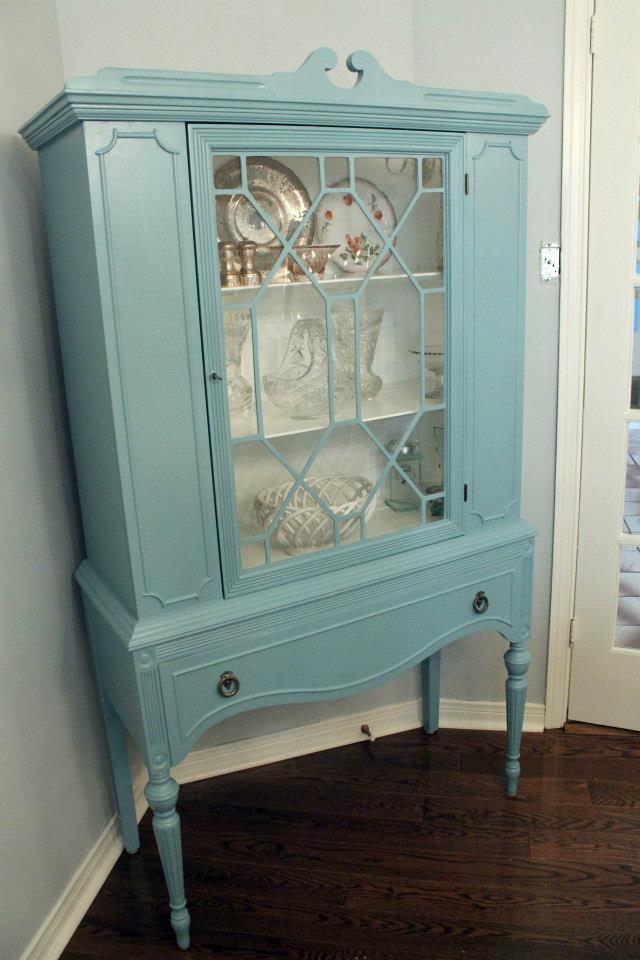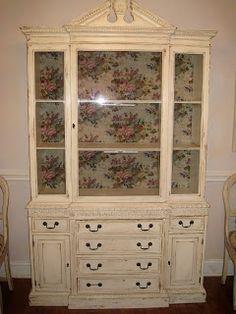The first image is the image on the left, the second image is the image on the right. Analyze the images presented: Is the assertion "The cabinet in the right image is light green." valid? Answer yes or no. No. The first image is the image on the left, the second image is the image on the right. Assess this claim about the two images: "A wooden cabinet in one image stands of long spindle legs, and has solid panels on each side of a wide glass door, and a full-width drawer with two pulls.". Correct or not? Answer yes or no. Yes. 